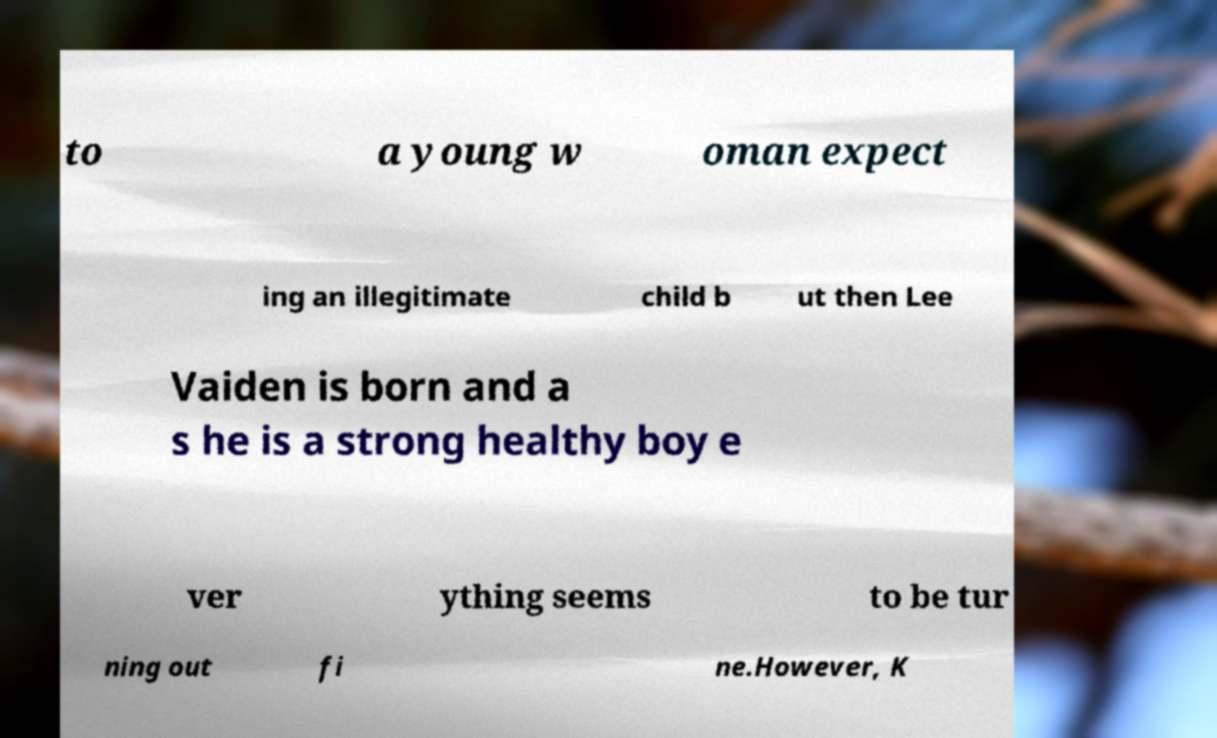For documentation purposes, I need the text within this image transcribed. Could you provide that? to a young w oman expect ing an illegitimate child b ut then Lee Vaiden is born and a s he is a strong healthy boy e ver ything seems to be tur ning out fi ne.However, K 